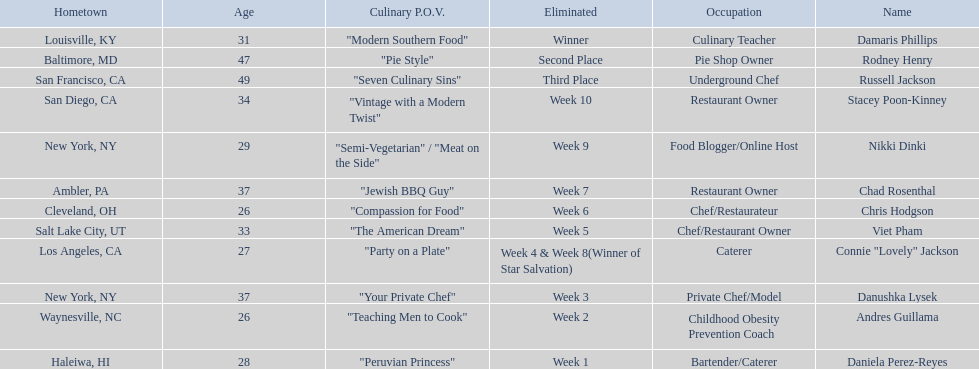Who are the  food network stars? Damaris Phillips, Rodney Henry, Russell Jackson, Stacey Poon-Kinney, Nikki Dinki, Chad Rosenthal, Chris Hodgson, Viet Pham, Connie "Lovely" Jackson, Danushka Lysek, Andres Guillama, Daniela Perez-Reyes. When did nikki dinki get eliminated? Week 9. When did viet pham get eliminated? Week 5. Which week came first? Week 5. Who was it that was eliminated week 5? Viet Pham. 